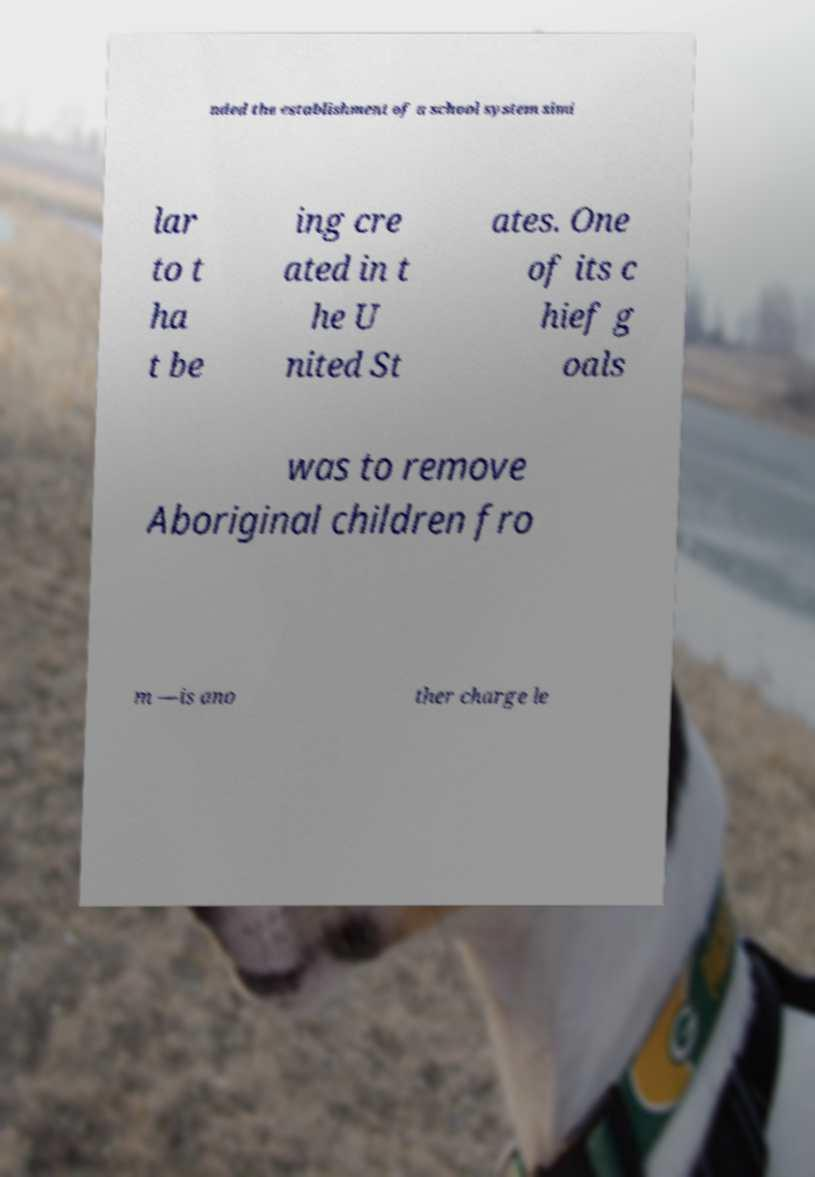I need the written content from this picture converted into text. Can you do that? nded the establishment of a school system simi lar to t ha t be ing cre ated in t he U nited St ates. One of its c hief g oals was to remove Aboriginal children fro m —is ano ther charge le 